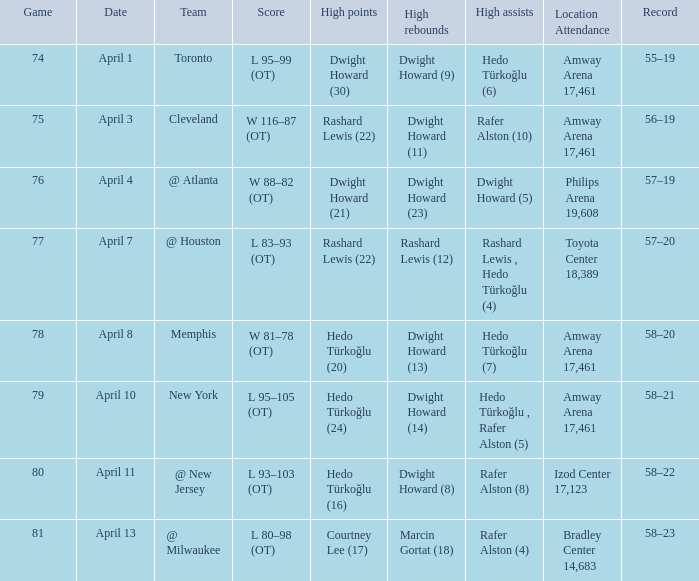In game 81, what was the final score? L 80–98 (OT). 